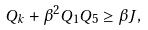Convert formula to latex. <formula><loc_0><loc_0><loc_500><loc_500>Q _ { k } + \beta ^ { 2 } Q _ { 1 } Q _ { 5 } \geq \beta J ,</formula> 